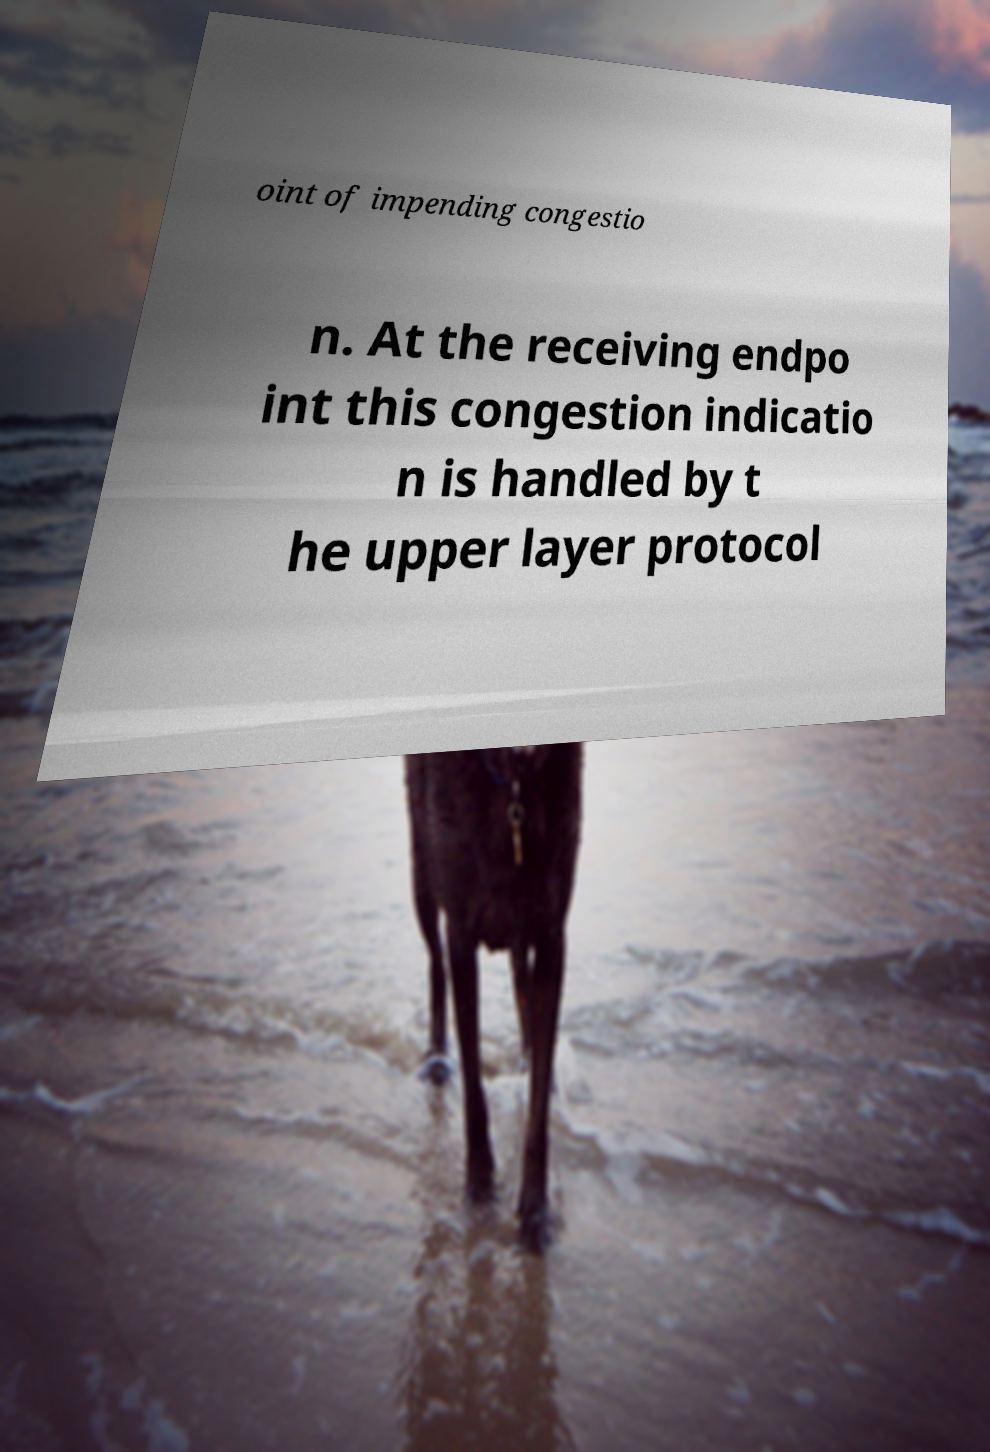Can you accurately transcribe the text from the provided image for me? oint of impending congestio n. At the receiving endpo int this congestion indicatio n is handled by t he upper layer protocol 